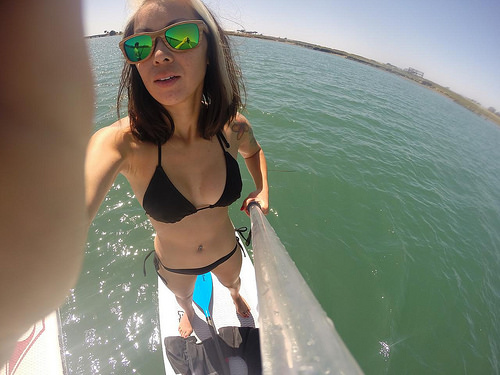<image>
Is the lady in the water? No. The lady is not contained within the water. These objects have a different spatial relationship. 